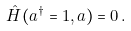<formula> <loc_0><loc_0><loc_500><loc_500>\hat { H } ( a ^ { \dagger } = 1 , a ) = 0 \, .</formula> 